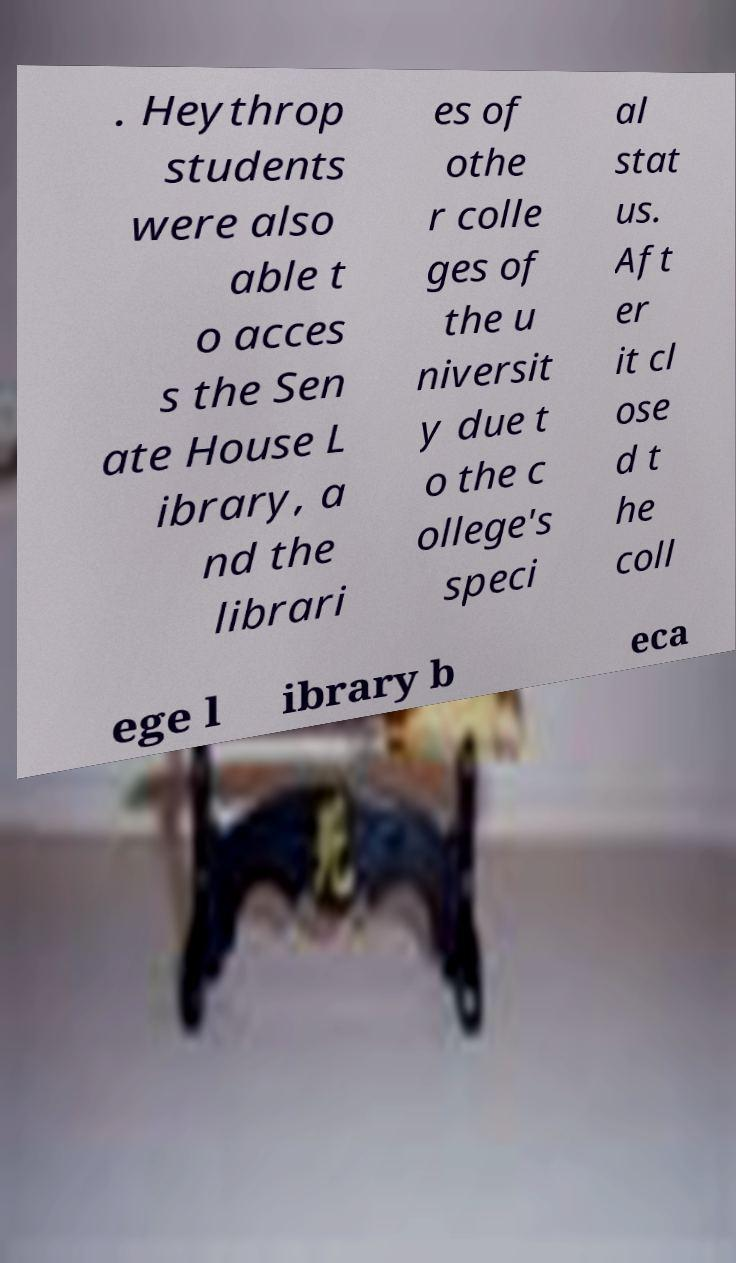Can you read and provide the text displayed in the image?This photo seems to have some interesting text. Can you extract and type it out for me? . Heythrop students were also able t o acces s the Sen ate House L ibrary, a nd the librari es of othe r colle ges of the u niversit y due t o the c ollege's speci al stat us. Aft er it cl ose d t he coll ege l ibrary b eca 